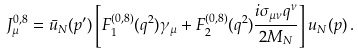Convert formula to latex. <formula><loc_0><loc_0><loc_500><loc_500>J _ { \mu } ^ { 0 , 8 } = \bar { u } _ { N } ( p ^ { \prime } ) \left [ F _ { 1 } ^ { ( 0 , 8 ) } ( q ^ { 2 } ) \gamma _ { \mu } + F _ { 2 } ^ { ( 0 , 8 ) } ( q ^ { 2 } ) \frac { i \sigma _ { \mu \nu } q ^ { \nu } } { 2 M _ { N } } \right ] u _ { N } ( p ) \, .</formula> 